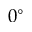Convert formula to latex. <formula><loc_0><loc_0><loc_500><loc_500>0 ^ { \circ }</formula> 